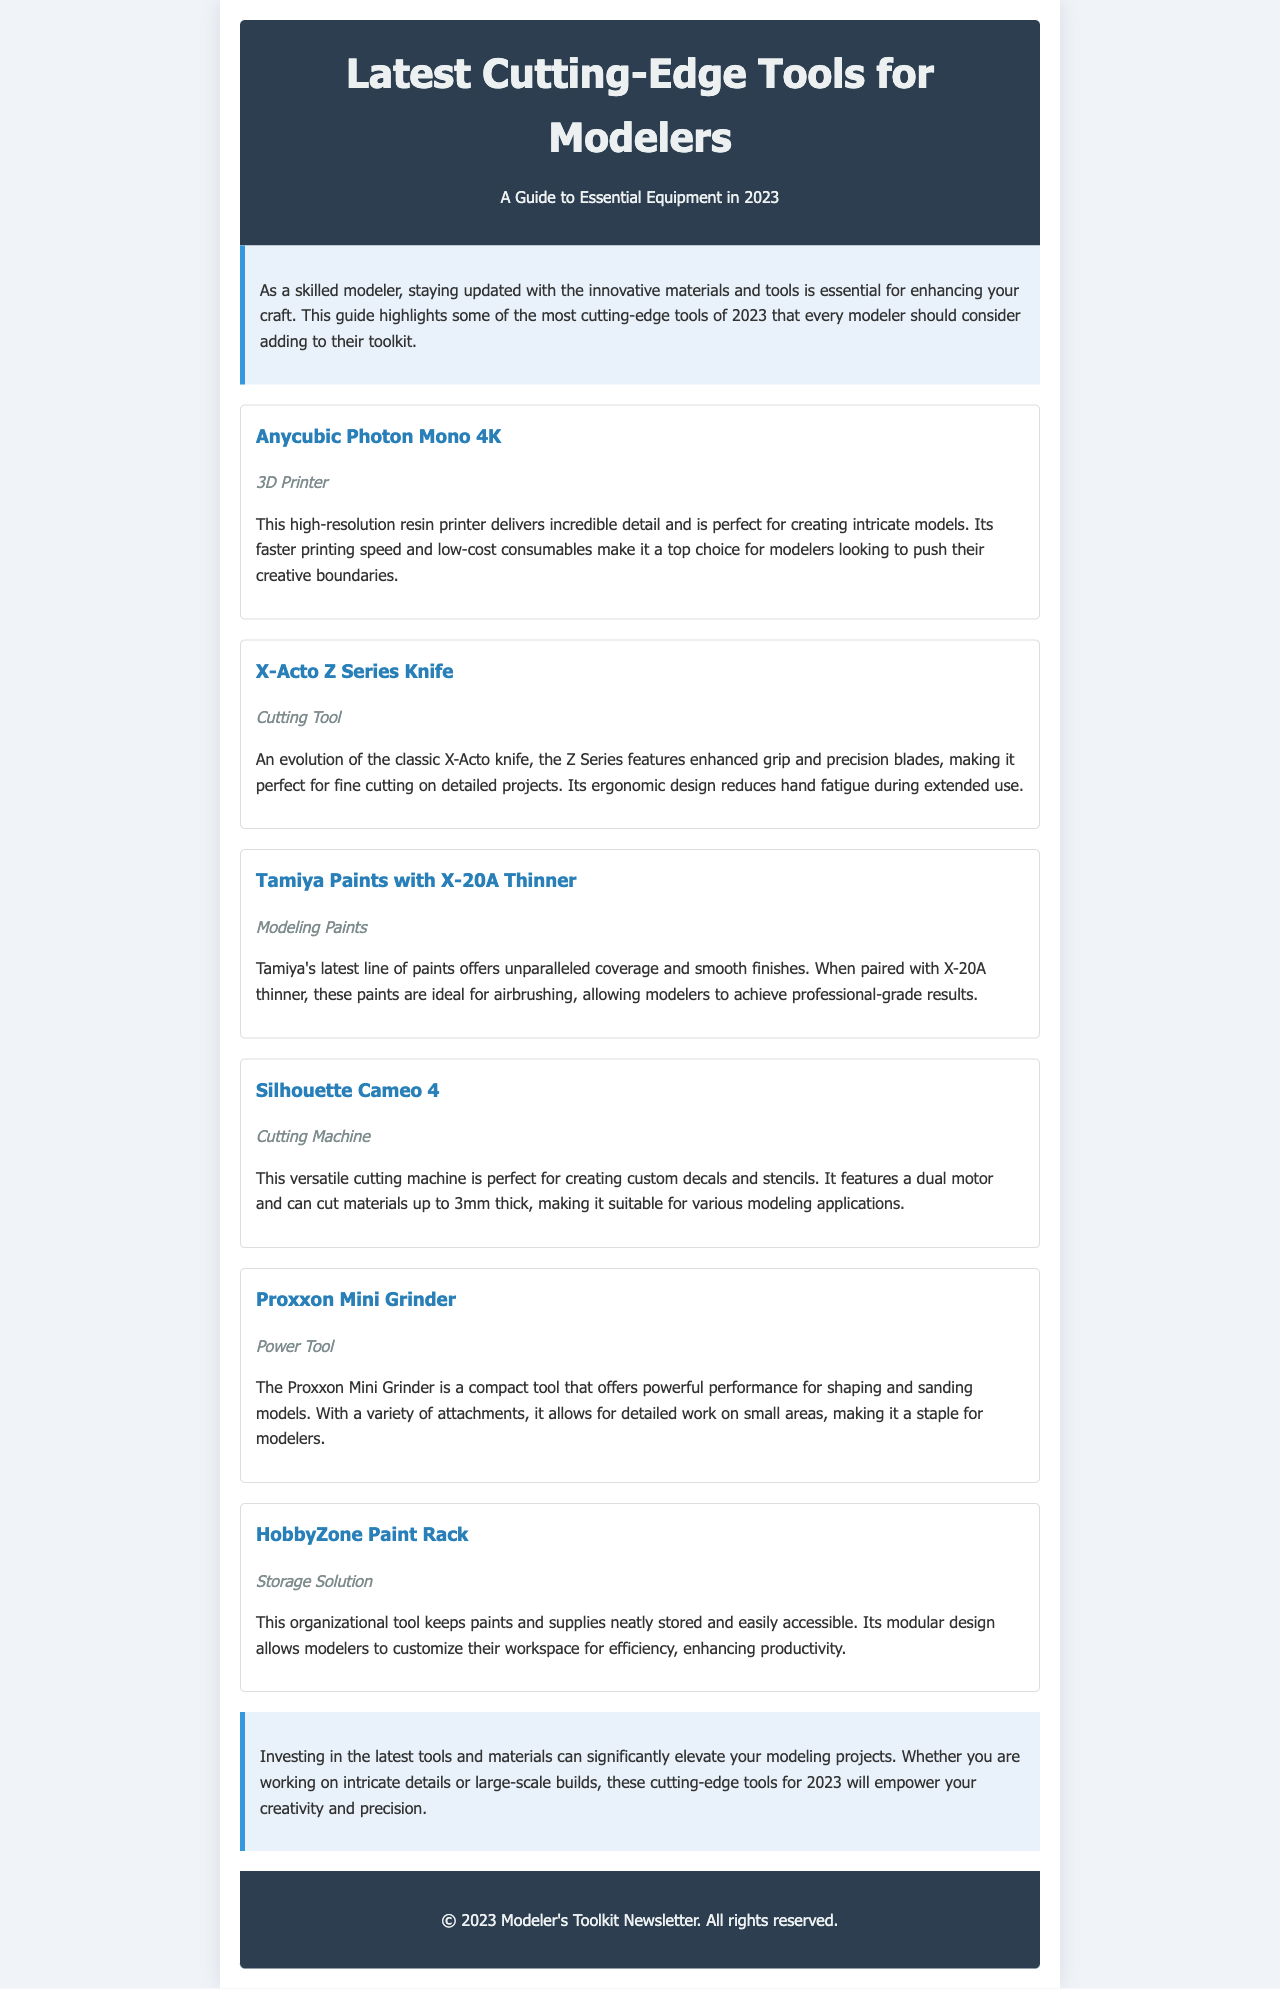What is the title of the newsletter? The title of the newsletter is prominently displayed at the top of the document.
Answer: Latest Cutting-Edge Tools for Modelers: A Guide to Essential Equipment in 2023 How many tools are featured in the newsletter? The number of tools can be determined by counting the individual tool sections listed within the document.
Answer: Six What type of tool is the Anycubic Photon Mono 4K? The tool type is specified in the document for each tool listed.
Answer: 3D Printer What is the primary benefit of using Tamiya Paints with X-20A Thinner? The document describes specific advantages of using the paint, highlighting its efficacy when paired with the thinner.
Answer: Professional-grade results Which cutting tool has an ergonomic design? The document explicitly states the features of each listed tool, including design qualities.
Answer: X-Acto Z Series Knife What organizational tool is mentioned for paint storage? The document names specific tools and their functions, including storage solutions.
Answer: HobbyZone Paint Rack What feature distinguishes the Silhouette Cameo 4? The special features of the cutting machine are described in the text, providing insight into its capabilities.
Answer: Dual motor What does the Proxxon Mini Grinder primarily offer? The focus of the tool's description points to its primary function in modeling.
Answer: Powerful performance What type of content does the conclusion provide? The conclusion summarizes the overall insights of the document and reflects on the tools mentioned.
Answer: Final thoughts on tool investment 